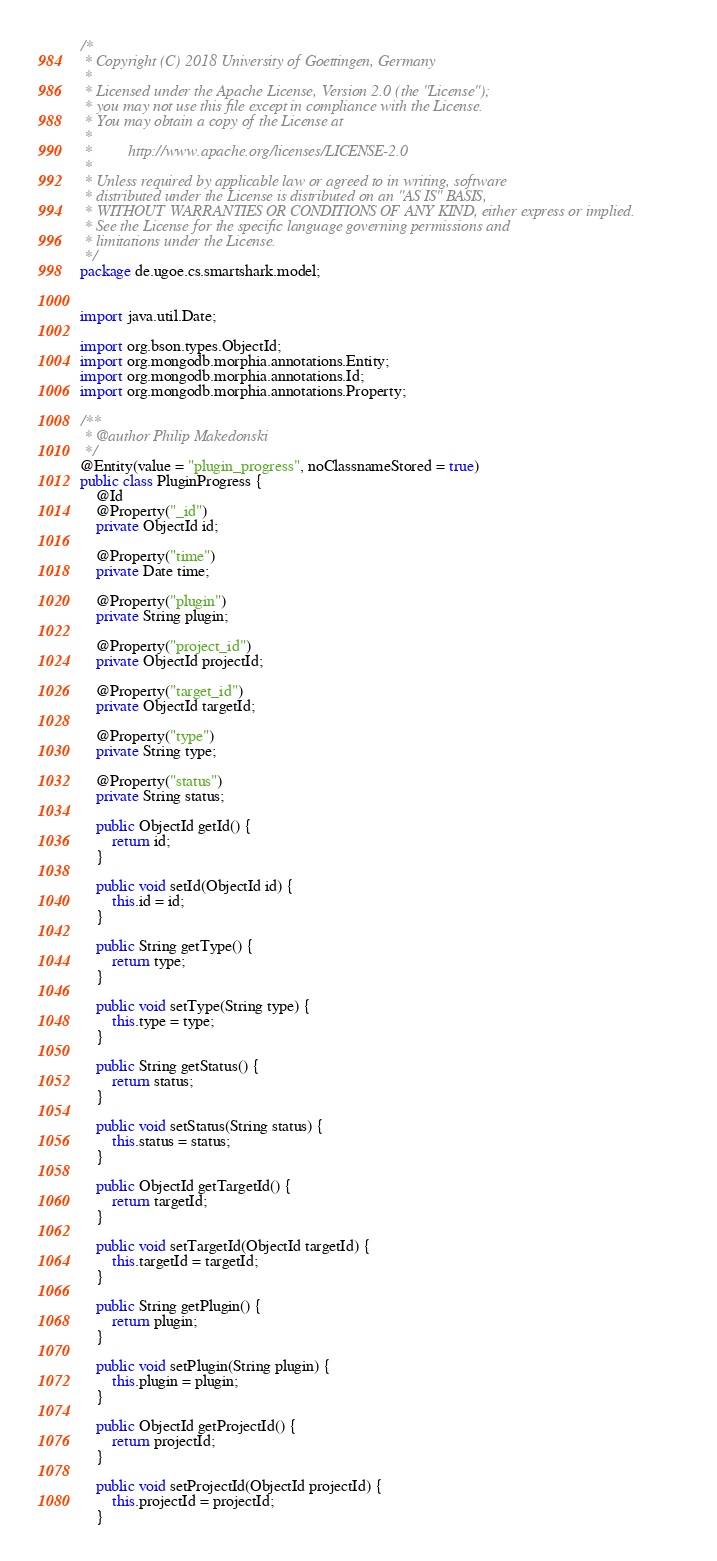Convert code to text. <code><loc_0><loc_0><loc_500><loc_500><_Java_>/*
 * Copyright (C) 2018 University of Goettingen, Germany
 *
 * Licensed under the Apache License, Version 2.0 (the "License");
 * you may not use this file except in compliance with the License.
 * You may obtain a copy of the License at
 *
 *         http://www.apache.org/licenses/LICENSE-2.0
 *
 * Unless required by applicable law or agreed to in writing, software
 * distributed under the License is distributed on an "AS IS" BASIS,
 * WITHOUT WARRANTIES OR CONDITIONS OF ANY KIND, either express or implied.
 * See the License for the specific language governing permissions and
 * limitations under the License.
 */
package de.ugoe.cs.smartshark.model;


import java.util.Date;

import org.bson.types.ObjectId;
import org.mongodb.morphia.annotations.Entity;
import org.mongodb.morphia.annotations.Id;
import org.mongodb.morphia.annotations.Property;

/**
 * @author Philip Makedonski
 */
@Entity(value = "plugin_progress", noClassnameStored = true)
public class PluginProgress {
    @Id
    @Property("_id")
    private ObjectId id;

    @Property("time")
    private Date time;

    @Property("plugin")
    private String plugin;

    @Property("project_id")
    private ObjectId projectId;

    @Property("target_id")
    private ObjectId targetId;

    @Property("type")
    private String type;

    @Property("status")
    private String status;

    public ObjectId getId() {
        return id;
    }

    public void setId(ObjectId id) {
        this.id = id;
    }

	public String getType() {
		return type;
	}

	public void setType(String type) {
		this.type = type;
	}

	public String getStatus() {
		return status;
	}

	public void setStatus(String status) {
		this.status = status;
	}

	public ObjectId getTargetId() {
		return targetId;
	}

	public void setTargetId(ObjectId targetId) {
		this.targetId = targetId;
	}

	public String getPlugin() {
		return plugin;
	}

	public void setPlugin(String plugin) {
		this.plugin = plugin;
	}

	public ObjectId getProjectId() {
		return projectId;
	}

	public void setProjectId(ObjectId projectId) {
		this.projectId = projectId;
	}
</code> 